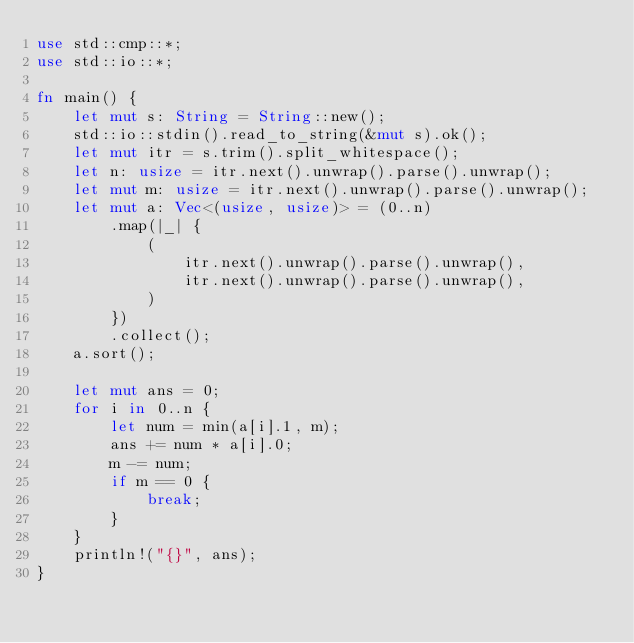<code> <loc_0><loc_0><loc_500><loc_500><_Rust_>use std::cmp::*;
use std::io::*;

fn main() {
    let mut s: String = String::new();
    std::io::stdin().read_to_string(&mut s).ok();
    let mut itr = s.trim().split_whitespace();
    let n: usize = itr.next().unwrap().parse().unwrap();
    let mut m: usize = itr.next().unwrap().parse().unwrap();
    let mut a: Vec<(usize, usize)> = (0..n)
        .map(|_| {
            (
                itr.next().unwrap().parse().unwrap(),
                itr.next().unwrap().parse().unwrap(),
            )
        })
        .collect();
    a.sort();

    let mut ans = 0;
    for i in 0..n {
        let num = min(a[i].1, m);
        ans += num * a[i].0;
        m -= num;
        if m == 0 {
            break;
        }
    }
    println!("{}", ans);
}
</code> 